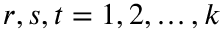<formula> <loc_0><loc_0><loc_500><loc_500>r , s , t = 1 , 2 , \dots , k</formula> 